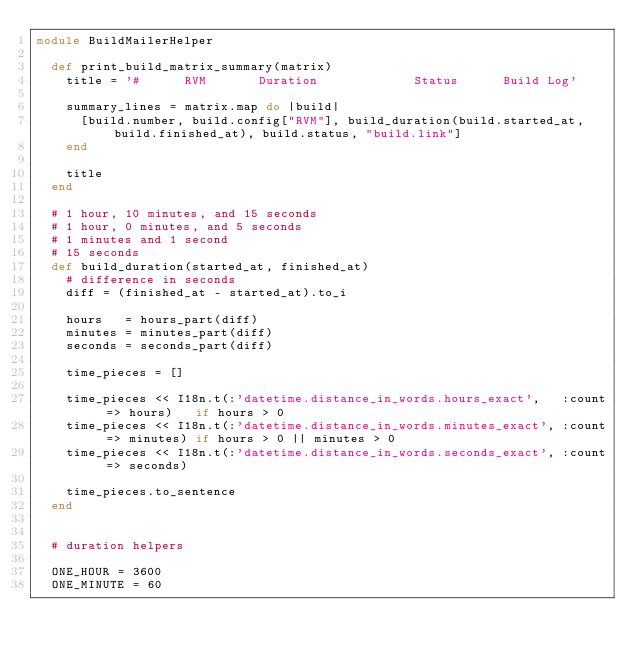<code> <loc_0><loc_0><loc_500><loc_500><_Ruby_>module BuildMailerHelper

  def print_build_matrix_summary(matrix)
    title = '#      RVM       Duration             Status      Build Log'

    summary_lines = matrix.map do |build|
      [build.number, build.config["RVM"], build_duration(build.started_at, build.finished_at), build.status, "build.link"]
    end

    title
  end

  # 1 hour, 10 minutes, and 15 seconds
  # 1 hour, 0 minutes, and 5 seconds
  # 1 minutes and 1 second
  # 15 seconds
  def build_duration(started_at, finished_at)
    # difference in seconds
    diff = (finished_at - started_at).to_i

    hours   = hours_part(diff)
    minutes = minutes_part(diff)
    seconds = seconds_part(diff)

    time_pieces = []

    time_pieces << I18n.t(:'datetime.distance_in_words.hours_exact',   :count => hours)   if hours > 0
    time_pieces << I18n.t(:'datetime.distance_in_words.minutes_exact', :count => minutes) if hours > 0 || minutes > 0
    time_pieces << I18n.t(:'datetime.distance_in_words.seconds_exact', :count => seconds)

    time_pieces.to_sentence
  end


  # duration helpers

  ONE_HOUR = 3600
  ONE_MINUTE = 60
</code> 